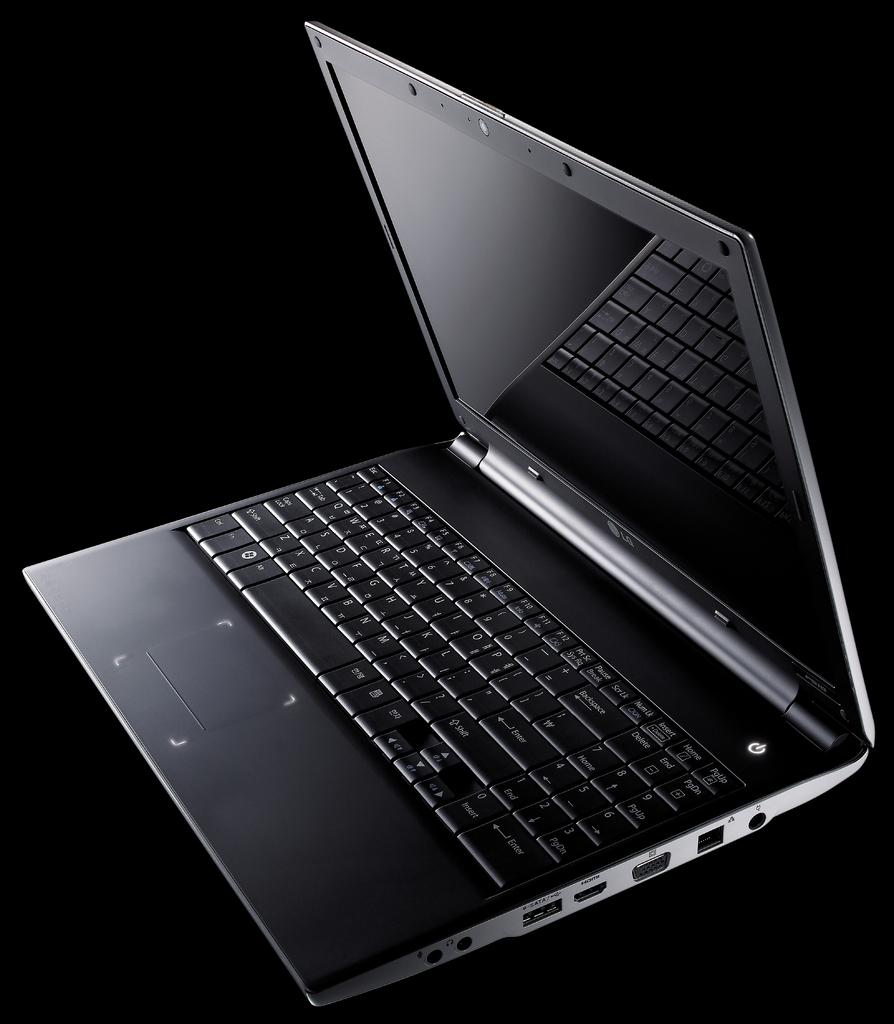<image>
Create a compact narrative representing the image presented. A sleek black LG portable lap top computer 